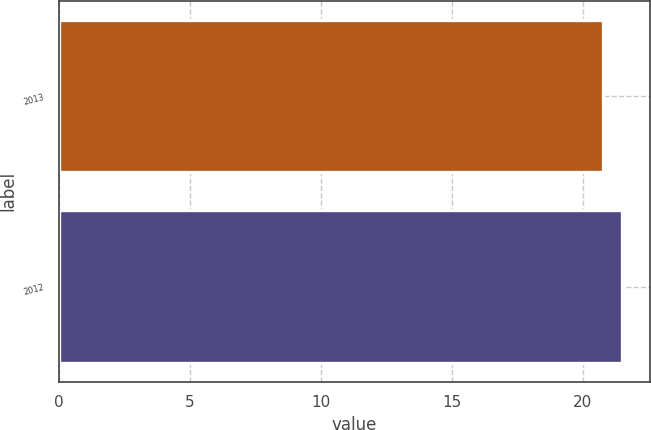<chart> <loc_0><loc_0><loc_500><loc_500><bar_chart><fcel>2013<fcel>2012<nl><fcel>20.79<fcel>21.51<nl></chart> 